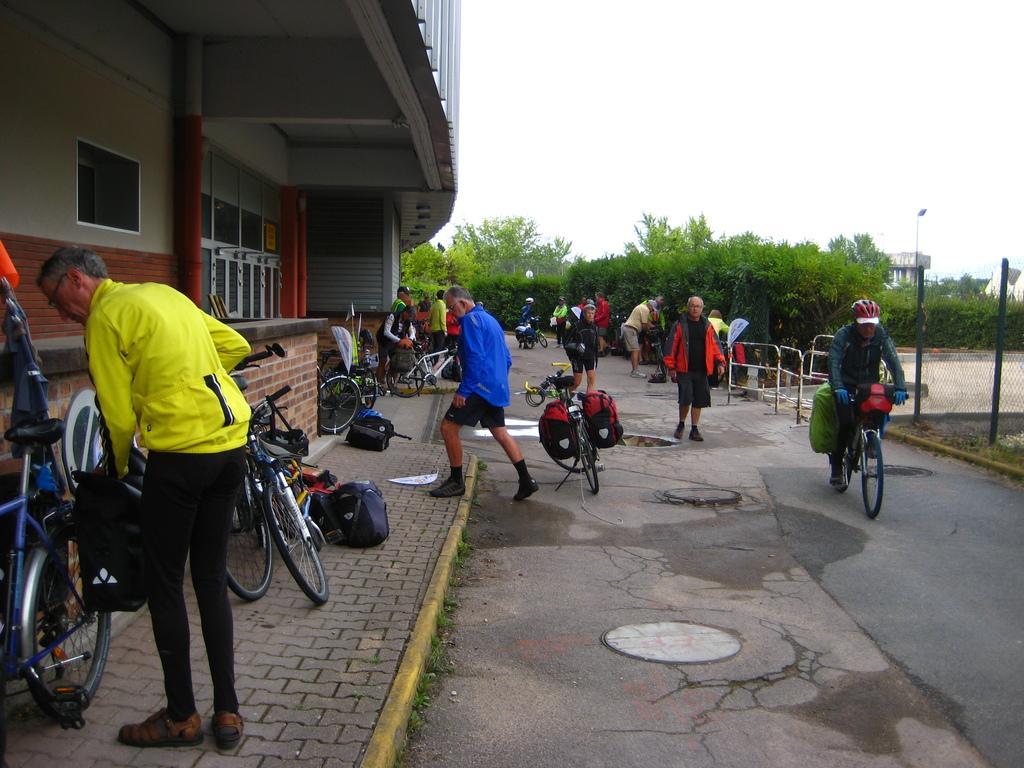In one or two sentences, can you explain what this image depicts? At the top we can see sky. These are trees. We can see a person riding a bicycle , wearing a helmet. We can see bicycles which are parked and bags near to the building. We can see persons walking and standing. This is a drainage cap. This is a road. 